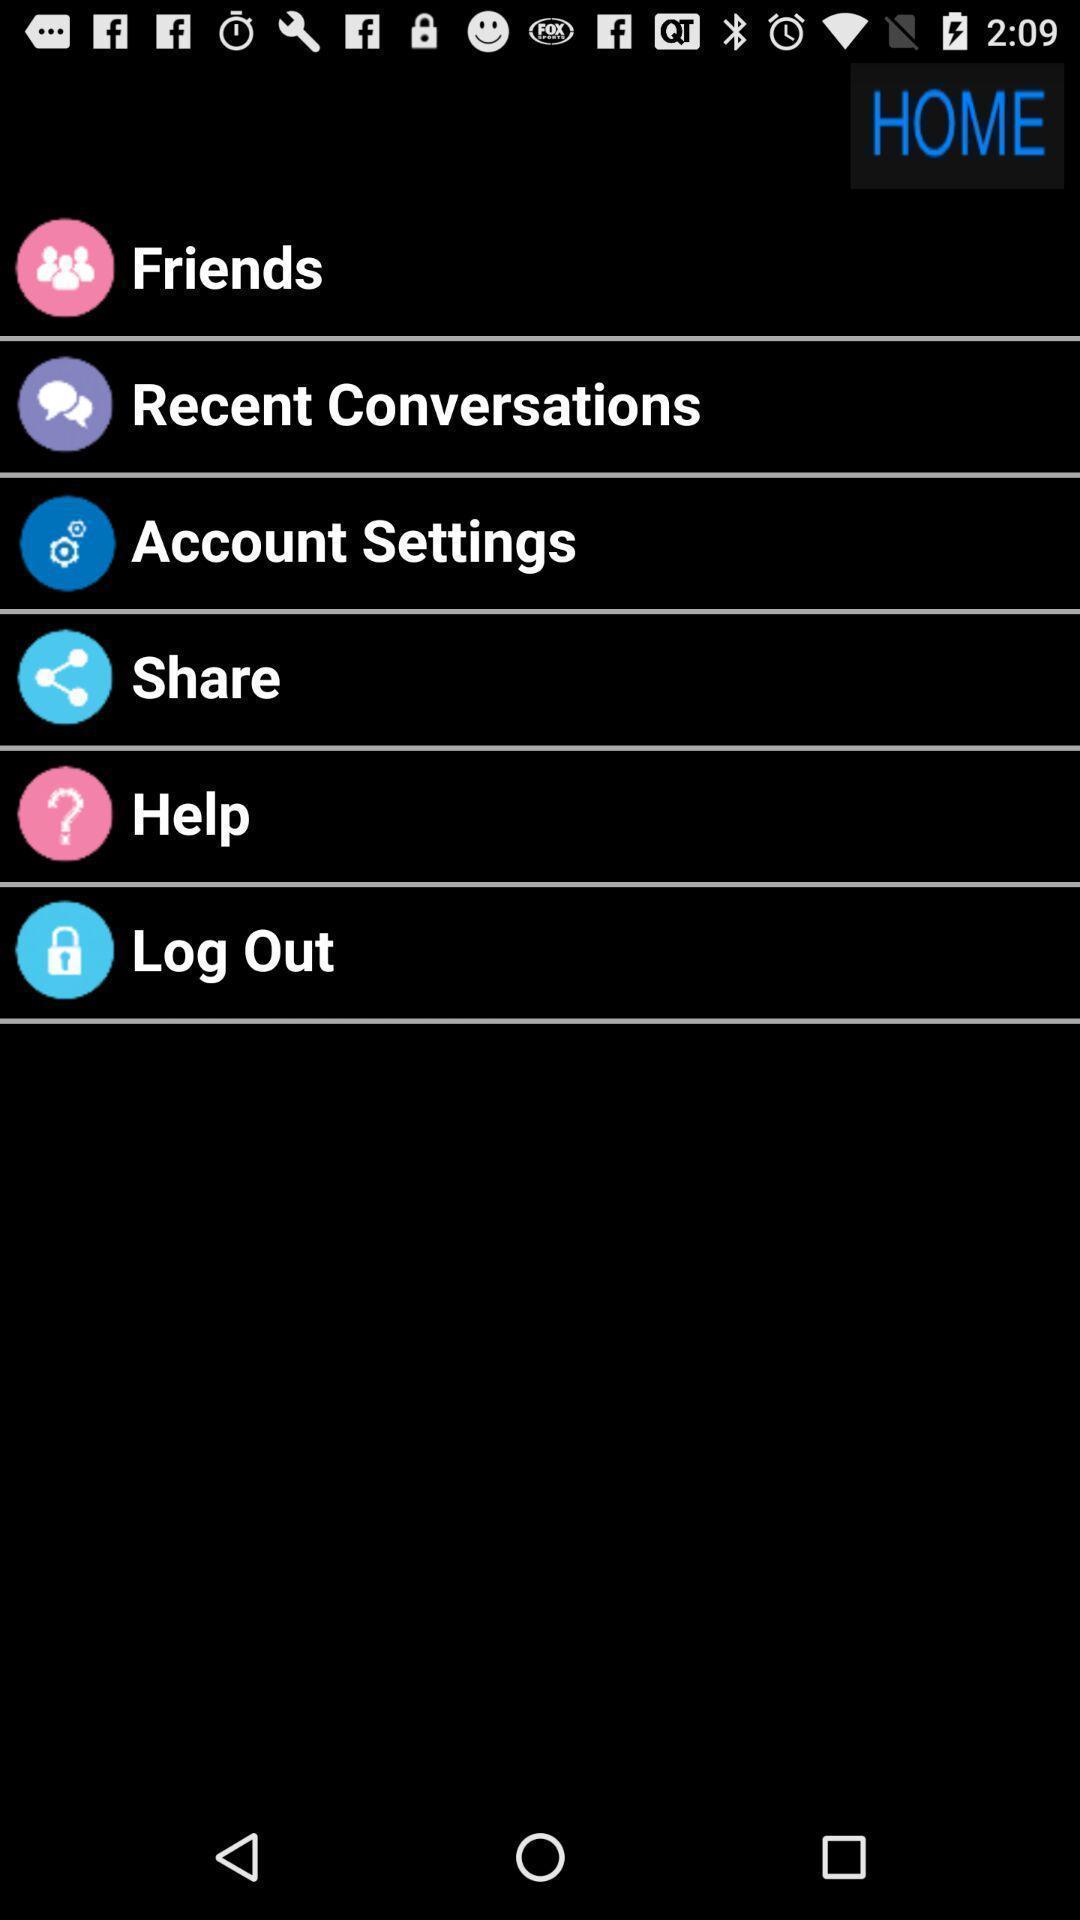What can you discern from this picture? Page showing home page. 